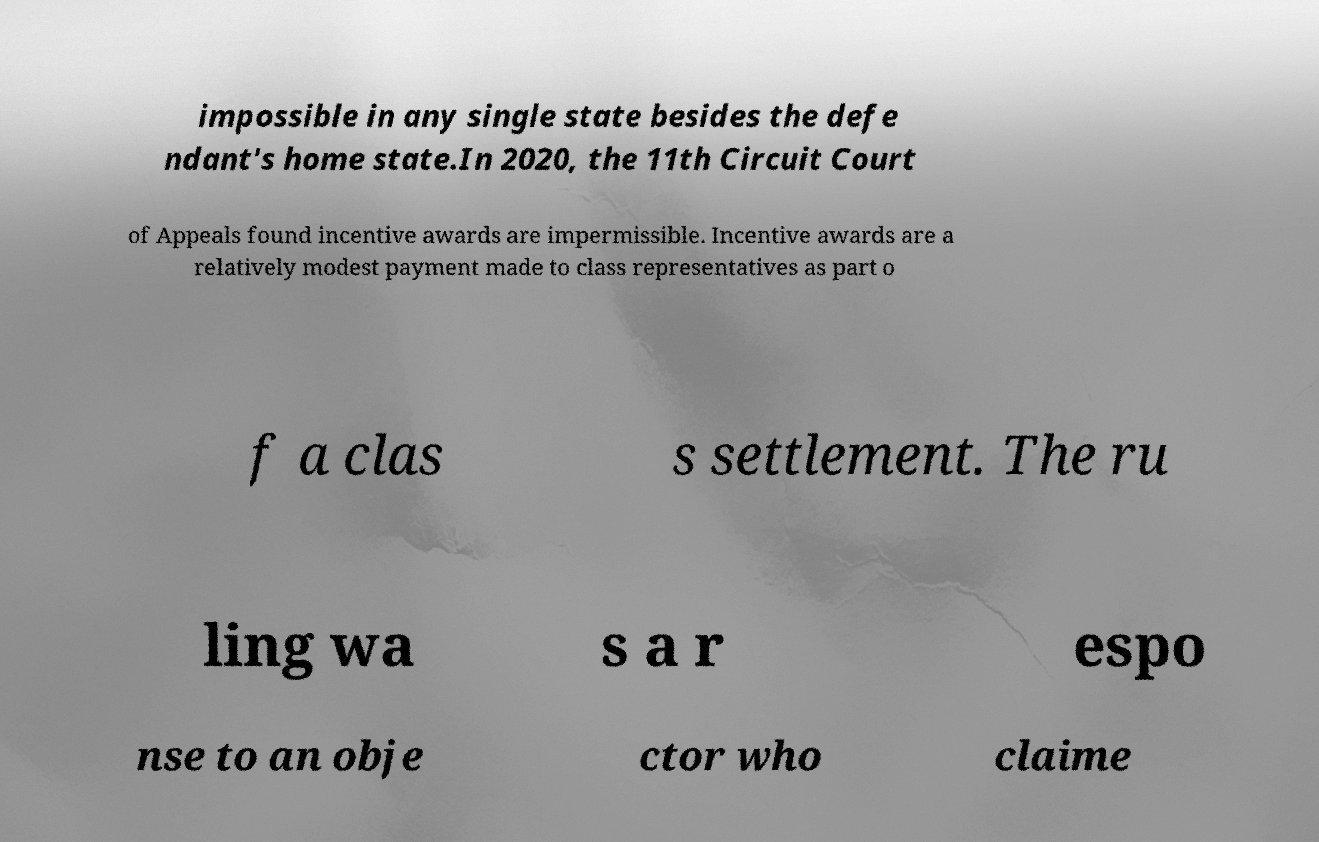Could you assist in decoding the text presented in this image and type it out clearly? impossible in any single state besides the defe ndant's home state.In 2020, the 11th Circuit Court of Appeals found incentive awards are impermissible. Incentive awards are a relatively modest payment made to class representatives as part o f a clas s settlement. The ru ling wa s a r espo nse to an obje ctor who claime 